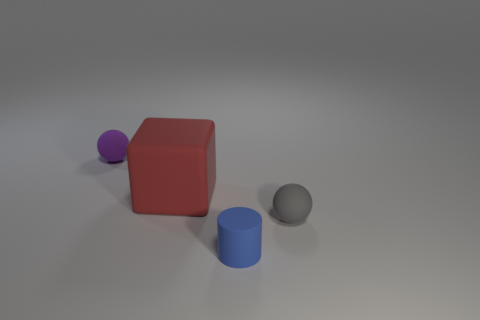Add 2 cyan rubber objects. How many objects exist? 6 Subtract all purple balls. How many balls are left? 1 Subtract all cylinders. How many objects are left? 3 Subtract 1 cylinders. How many cylinders are left? 0 Subtract 0 green balls. How many objects are left? 4 Subtract all brown blocks. Subtract all red cylinders. How many blocks are left? 1 Subtract all small brown cubes. Subtract all small cylinders. How many objects are left? 3 Add 3 small purple balls. How many small purple balls are left? 4 Add 3 big red shiny cylinders. How many big red shiny cylinders exist? 3 